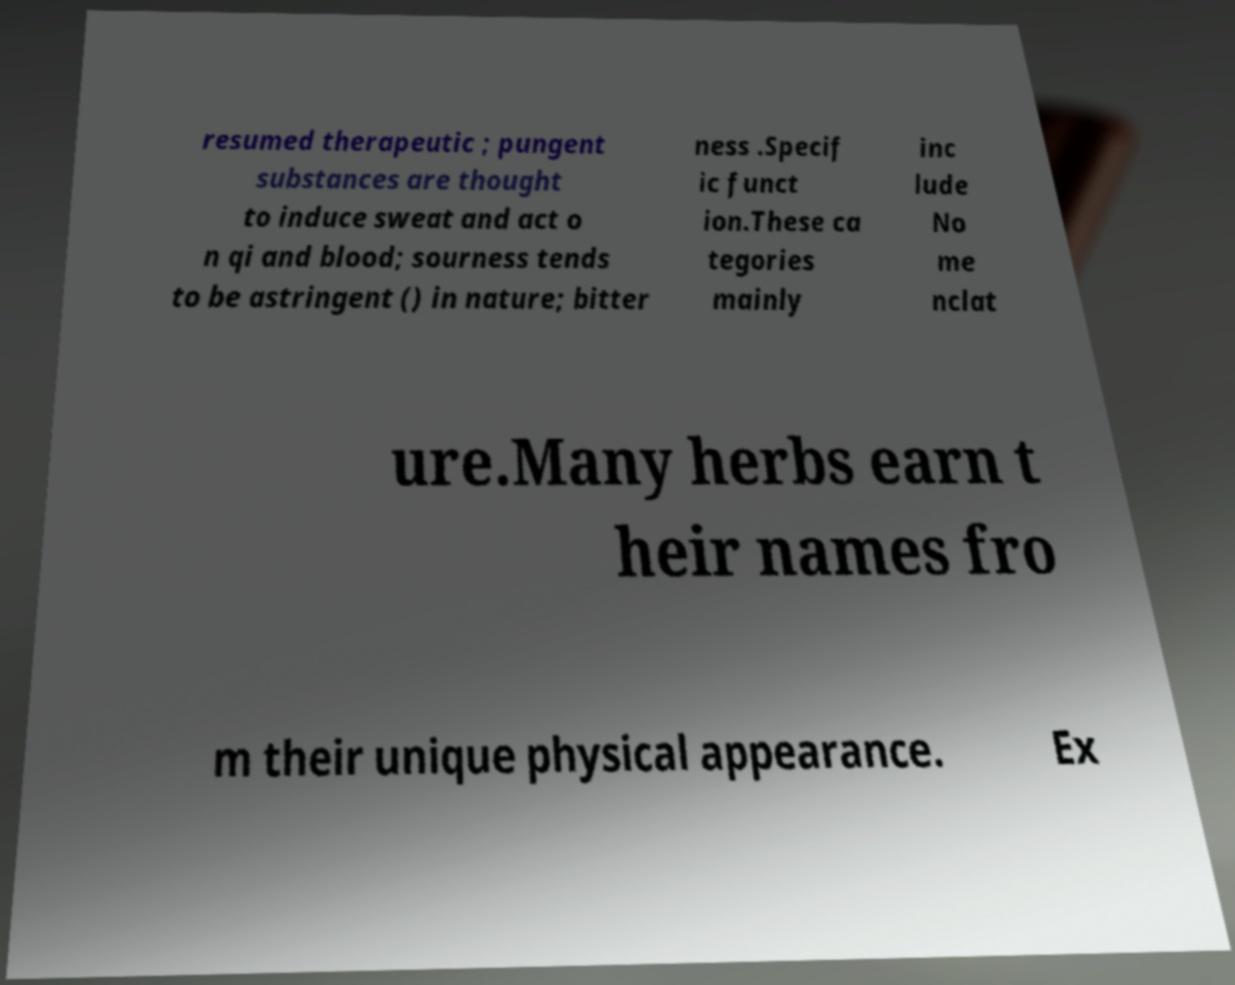Can you read and provide the text displayed in the image?This photo seems to have some interesting text. Can you extract and type it out for me? resumed therapeutic ; pungent substances are thought to induce sweat and act o n qi and blood; sourness tends to be astringent () in nature; bitter ness .Specif ic funct ion.These ca tegories mainly inc lude No me nclat ure.Many herbs earn t heir names fro m their unique physical appearance. Ex 